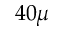Convert formula to latex. <formula><loc_0><loc_0><loc_500><loc_500>4 0 \mu</formula> 